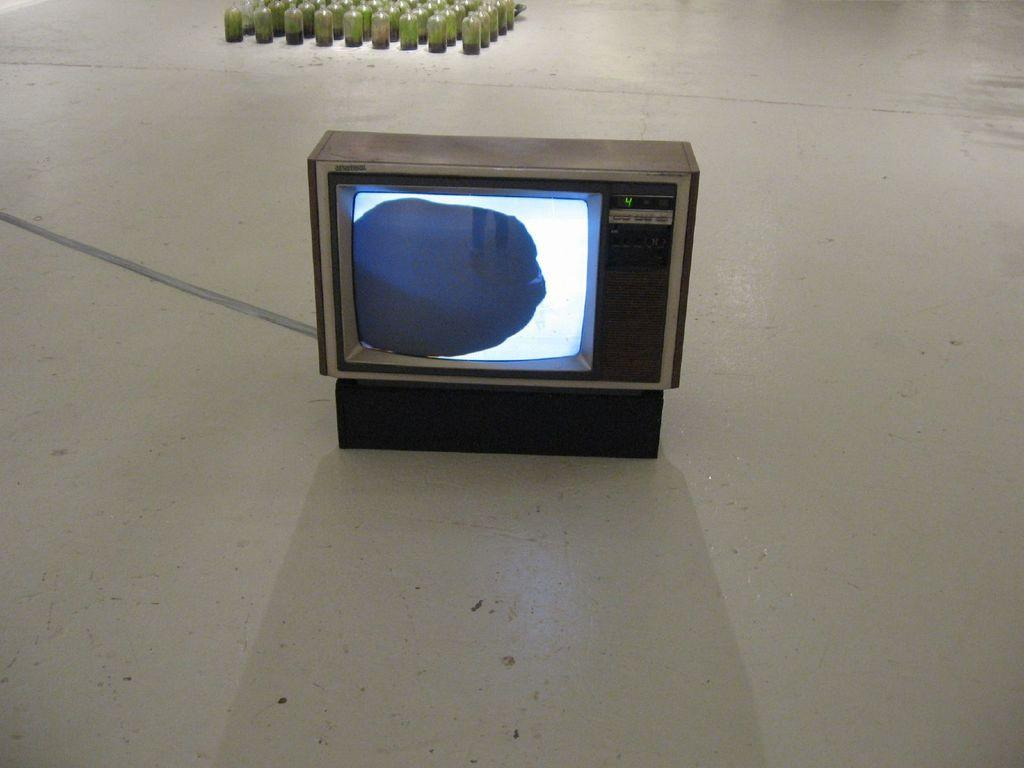<image>
Provide a brief description of the given image. An old styled television displays the channel 4 in green. 